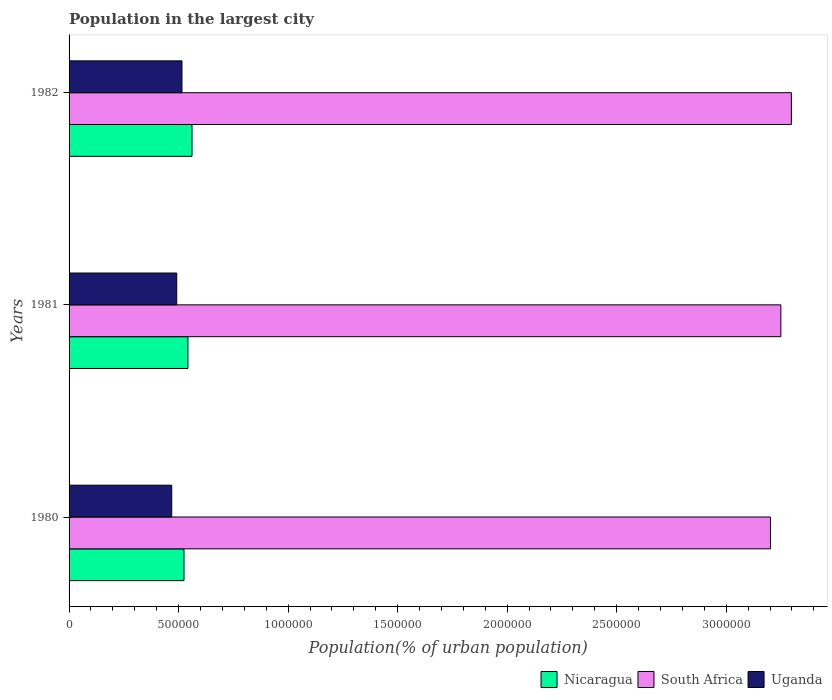How many groups of bars are there?
Provide a succinct answer. 3. Are the number of bars on each tick of the Y-axis equal?
Your response must be concise. Yes. How many bars are there on the 2nd tick from the top?
Give a very brief answer. 3. How many bars are there on the 2nd tick from the bottom?
Offer a terse response. 3. In how many cases, is the number of bars for a given year not equal to the number of legend labels?
Your response must be concise. 0. What is the population in the largest city in Uganda in 1981?
Your answer should be very brief. 4.91e+05. Across all years, what is the maximum population in the largest city in South Africa?
Offer a terse response. 3.30e+06. Across all years, what is the minimum population in the largest city in South Africa?
Keep it short and to the point. 3.20e+06. In which year was the population in the largest city in Uganda maximum?
Make the answer very short. 1982. In which year was the population in the largest city in Nicaragua minimum?
Your response must be concise. 1980. What is the total population in the largest city in Nicaragua in the graph?
Provide a succinct answer. 1.63e+06. What is the difference between the population in the largest city in Uganda in 1980 and that in 1982?
Your answer should be very brief. -4.69e+04. What is the difference between the population in the largest city in South Africa in 1980 and the population in the largest city in Nicaragua in 1982?
Give a very brief answer. 2.64e+06. What is the average population in the largest city in Nicaragua per year?
Give a very brief answer. 5.43e+05. In the year 1981, what is the difference between the population in the largest city in South Africa and population in the largest city in Nicaragua?
Your answer should be compact. 2.71e+06. In how many years, is the population in the largest city in Nicaragua greater than 1000000 %?
Give a very brief answer. 0. What is the ratio of the population in the largest city in Uganda in 1980 to that in 1982?
Provide a short and direct response. 0.91. Is the population in the largest city in Uganda in 1981 less than that in 1982?
Provide a short and direct response. Yes. What is the difference between the highest and the second highest population in the largest city in South Africa?
Your answer should be compact. 4.81e+04. What is the difference between the highest and the lowest population in the largest city in Uganda?
Make the answer very short. 4.69e+04. In how many years, is the population in the largest city in Uganda greater than the average population in the largest city in Uganda taken over all years?
Ensure brevity in your answer.  1. Is the sum of the population in the largest city in Uganda in 1981 and 1982 greater than the maximum population in the largest city in South Africa across all years?
Give a very brief answer. No. What does the 1st bar from the top in 1981 represents?
Your answer should be very brief. Uganda. What does the 1st bar from the bottom in 1982 represents?
Provide a succinct answer. Nicaragua. Is it the case that in every year, the sum of the population in the largest city in Uganda and population in the largest city in South Africa is greater than the population in the largest city in Nicaragua?
Your response must be concise. Yes. How many bars are there?
Provide a short and direct response. 9. Are all the bars in the graph horizontal?
Offer a very short reply. Yes. How many years are there in the graph?
Your response must be concise. 3. Does the graph contain grids?
Provide a succinct answer. No. Where does the legend appear in the graph?
Keep it short and to the point. Bottom right. How are the legend labels stacked?
Keep it short and to the point. Horizontal. What is the title of the graph?
Give a very brief answer. Population in the largest city. What is the label or title of the X-axis?
Provide a short and direct response. Population(% of urban population). What is the Population(% of urban population) in Nicaragua in 1980?
Offer a terse response. 5.25e+05. What is the Population(% of urban population) in South Africa in 1980?
Give a very brief answer. 3.20e+06. What is the Population(% of urban population) in Uganda in 1980?
Give a very brief answer. 4.69e+05. What is the Population(% of urban population) of Nicaragua in 1981?
Give a very brief answer. 5.43e+05. What is the Population(% of urban population) of South Africa in 1981?
Your response must be concise. 3.25e+06. What is the Population(% of urban population) of Uganda in 1981?
Make the answer very short. 4.91e+05. What is the Population(% of urban population) of Nicaragua in 1982?
Make the answer very short. 5.61e+05. What is the Population(% of urban population) of South Africa in 1982?
Your response must be concise. 3.30e+06. What is the Population(% of urban population) in Uganda in 1982?
Your answer should be compact. 5.15e+05. Across all years, what is the maximum Population(% of urban population) of Nicaragua?
Keep it short and to the point. 5.61e+05. Across all years, what is the maximum Population(% of urban population) of South Africa?
Provide a succinct answer. 3.30e+06. Across all years, what is the maximum Population(% of urban population) in Uganda?
Offer a very short reply. 5.15e+05. Across all years, what is the minimum Population(% of urban population) in Nicaragua?
Provide a short and direct response. 5.25e+05. Across all years, what is the minimum Population(% of urban population) of South Africa?
Provide a succinct answer. 3.20e+06. Across all years, what is the minimum Population(% of urban population) in Uganda?
Offer a terse response. 4.69e+05. What is the total Population(% of urban population) of Nicaragua in the graph?
Keep it short and to the point. 1.63e+06. What is the total Population(% of urban population) in South Africa in the graph?
Make the answer very short. 9.75e+06. What is the total Population(% of urban population) in Uganda in the graph?
Make the answer very short. 1.48e+06. What is the difference between the Population(% of urban population) in Nicaragua in 1980 and that in 1981?
Provide a succinct answer. -1.79e+04. What is the difference between the Population(% of urban population) in South Africa in 1980 and that in 1981?
Your answer should be compact. -4.74e+04. What is the difference between the Population(% of urban population) of Uganda in 1980 and that in 1981?
Provide a succinct answer. -2.29e+04. What is the difference between the Population(% of urban population) of Nicaragua in 1980 and that in 1982?
Offer a very short reply. -3.65e+04. What is the difference between the Population(% of urban population) of South Africa in 1980 and that in 1982?
Offer a very short reply. -9.55e+04. What is the difference between the Population(% of urban population) in Uganda in 1980 and that in 1982?
Your answer should be compact. -4.69e+04. What is the difference between the Population(% of urban population) in Nicaragua in 1981 and that in 1982?
Your answer should be compact. -1.86e+04. What is the difference between the Population(% of urban population) of South Africa in 1981 and that in 1982?
Make the answer very short. -4.81e+04. What is the difference between the Population(% of urban population) in Uganda in 1981 and that in 1982?
Offer a very short reply. -2.40e+04. What is the difference between the Population(% of urban population) in Nicaragua in 1980 and the Population(% of urban population) in South Africa in 1981?
Offer a terse response. -2.72e+06. What is the difference between the Population(% of urban population) in Nicaragua in 1980 and the Population(% of urban population) in Uganda in 1981?
Give a very brief answer. 3.32e+04. What is the difference between the Population(% of urban population) of South Africa in 1980 and the Population(% of urban population) of Uganda in 1981?
Make the answer very short. 2.71e+06. What is the difference between the Population(% of urban population) of Nicaragua in 1980 and the Population(% of urban population) of South Africa in 1982?
Give a very brief answer. -2.77e+06. What is the difference between the Population(% of urban population) of Nicaragua in 1980 and the Population(% of urban population) of Uganda in 1982?
Keep it short and to the point. 9246. What is the difference between the Population(% of urban population) in South Africa in 1980 and the Population(% of urban population) in Uganda in 1982?
Offer a terse response. 2.69e+06. What is the difference between the Population(% of urban population) of Nicaragua in 1981 and the Population(% of urban population) of South Africa in 1982?
Offer a terse response. -2.75e+06. What is the difference between the Population(% of urban population) in Nicaragua in 1981 and the Population(% of urban population) in Uganda in 1982?
Your answer should be compact. 2.72e+04. What is the difference between the Population(% of urban population) of South Africa in 1981 and the Population(% of urban population) of Uganda in 1982?
Your answer should be very brief. 2.73e+06. What is the average Population(% of urban population) of Nicaragua per year?
Give a very brief answer. 5.43e+05. What is the average Population(% of urban population) in South Africa per year?
Keep it short and to the point. 3.25e+06. What is the average Population(% of urban population) of Uganda per year?
Offer a terse response. 4.92e+05. In the year 1980, what is the difference between the Population(% of urban population) of Nicaragua and Population(% of urban population) of South Africa?
Your answer should be compact. -2.68e+06. In the year 1980, what is the difference between the Population(% of urban population) in Nicaragua and Population(% of urban population) in Uganda?
Offer a terse response. 5.61e+04. In the year 1980, what is the difference between the Population(% of urban population) of South Africa and Population(% of urban population) of Uganda?
Your answer should be compact. 2.73e+06. In the year 1981, what is the difference between the Population(% of urban population) in Nicaragua and Population(% of urban population) in South Africa?
Your answer should be compact. -2.71e+06. In the year 1981, what is the difference between the Population(% of urban population) in Nicaragua and Population(% of urban population) in Uganda?
Your answer should be very brief. 5.12e+04. In the year 1981, what is the difference between the Population(% of urban population) in South Africa and Population(% of urban population) in Uganda?
Ensure brevity in your answer.  2.76e+06. In the year 1982, what is the difference between the Population(% of urban population) of Nicaragua and Population(% of urban population) of South Africa?
Ensure brevity in your answer.  -2.74e+06. In the year 1982, what is the difference between the Population(% of urban population) in Nicaragua and Population(% of urban population) in Uganda?
Offer a terse response. 4.58e+04. In the year 1982, what is the difference between the Population(% of urban population) of South Africa and Population(% of urban population) of Uganda?
Provide a short and direct response. 2.78e+06. What is the ratio of the Population(% of urban population) in Nicaragua in 1980 to that in 1981?
Give a very brief answer. 0.97. What is the ratio of the Population(% of urban population) of South Africa in 1980 to that in 1981?
Offer a terse response. 0.99. What is the ratio of the Population(% of urban population) of Uganda in 1980 to that in 1981?
Ensure brevity in your answer.  0.95. What is the ratio of the Population(% of urban population) of Nicaragua in 1980 to that in 1982?
Your answer should be compact. 0.93. What is the ratio of the Population(% of urban population) of South Africa in 1980 to that in 1982?
Ensure brevity in your answer.  0.97. What is the ratio of the Population(% of urban population) in Uganda in 1980 to that in 1982?
Make the answer very short. 0.91. What is the ratio of the Population(% of urban population) in Nicaragua in 1981 to that in 1982?
Offer a very short reply. 0.97. What is the ratio of the Population(% of urban population) in South Africa in 1981 to that in 1982?
Provide a short and direct response. 0.99. What is the ratio of the Population(% of urban population) of Uganda in 1981 to that in 1982?
Your answer should be very brief. 0.95. What is the difference between the highest and the second highest Population(% of urban population) of Nicaragua?
Ensure brevity in your answer.  1.86e+04. What is the difference between the highest and the second highest Population(% of urban population) of South Africa?
Ensure brevity in your answer.  4.81e+04. What is the difference between the highest and the second highest Population(% of urban population) in Uganda?
Keep it short and to the point. 2.40e+04. What is the difference between the highest and the lowest Population(% of urban population) of Nicaragua?
Keep it short and to the point. 3.65e+04. What is the difference between the highest and the lowest Population(% of urban population) in South Africa?
Give a very brief answer. 9.55e+04. What is the difference between the highest and the lowest Population(% of urban population) of Uganda?
Give a very brief answer. 4.69e+04. 